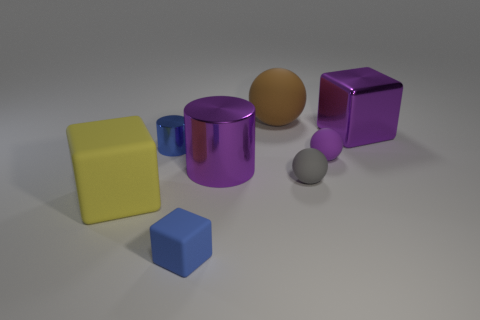Subtract all large blocks. How many blocks are left? 1 Subtract 1 balls. How many balls are left? 2 Add 1 large red shiny cylinders. How many objects exist? 9 Subtract all balls. How many objects are left? 5 Add 1 tiny cylinders. How many tiny cylinders exist? 2 Subtract 0 blue balls. How many objects are left? 8 Subtract all tiny blue rubber blocks. Subtract all metallic objects. How many objects are left? 4 Add 3 big yellow things. How many big yellow things are left? 4 